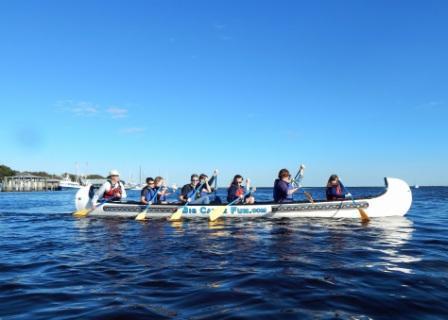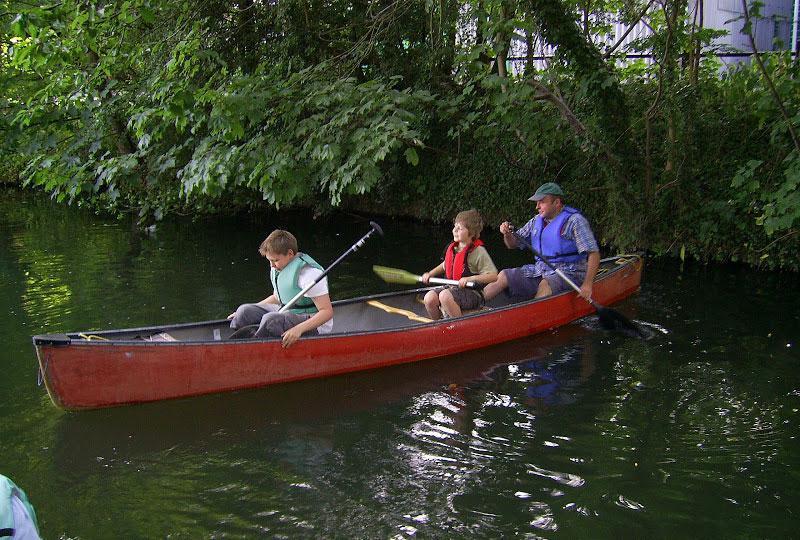The first image is the image on the left, the second image is the image on the right. Assess this claim about the two images: "The left and right image contains a total of two boats.". Correct or not? Answer yes or no. Yes. The first image is the image on the left, the second image is the image on the right. Analyze the images presented: Is the assertion "The right image shows one canoe, a leftward-headed red canoe with at least three rowers." valid? Answer yes or no. Yes. 